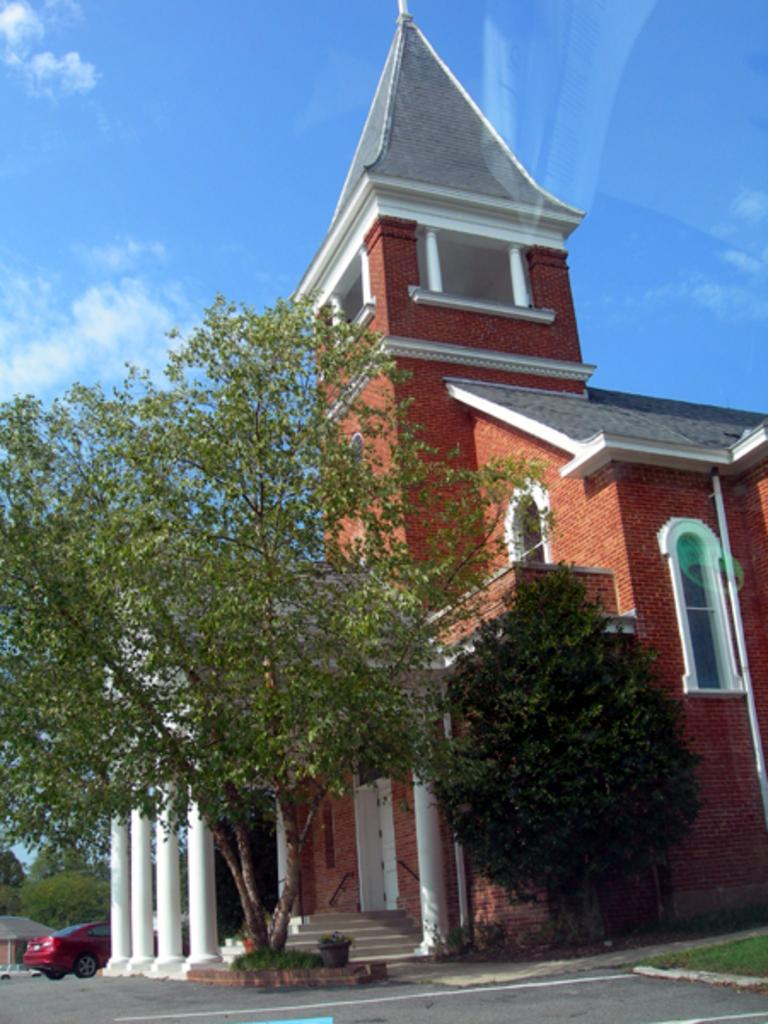What type of pathway is visible in the image? There is a road in the image. What type of vegetation can be seen in the image? There are plants and trees in the image. What type of structures are present in the image? There are buildings in the image. What mode of transportation is visible in the image? There is a car in the image. What is visible at the top of the image? The sky is visible at the top of the image. What color are the cakes being served in the image? There are no cakes present in the image; it features a road, plants, trees, buildings, a car, and the sky. How does the temper of the person driving the car affect the image? There is no information about the temper of the person driving the car, and it does not affect the image. 